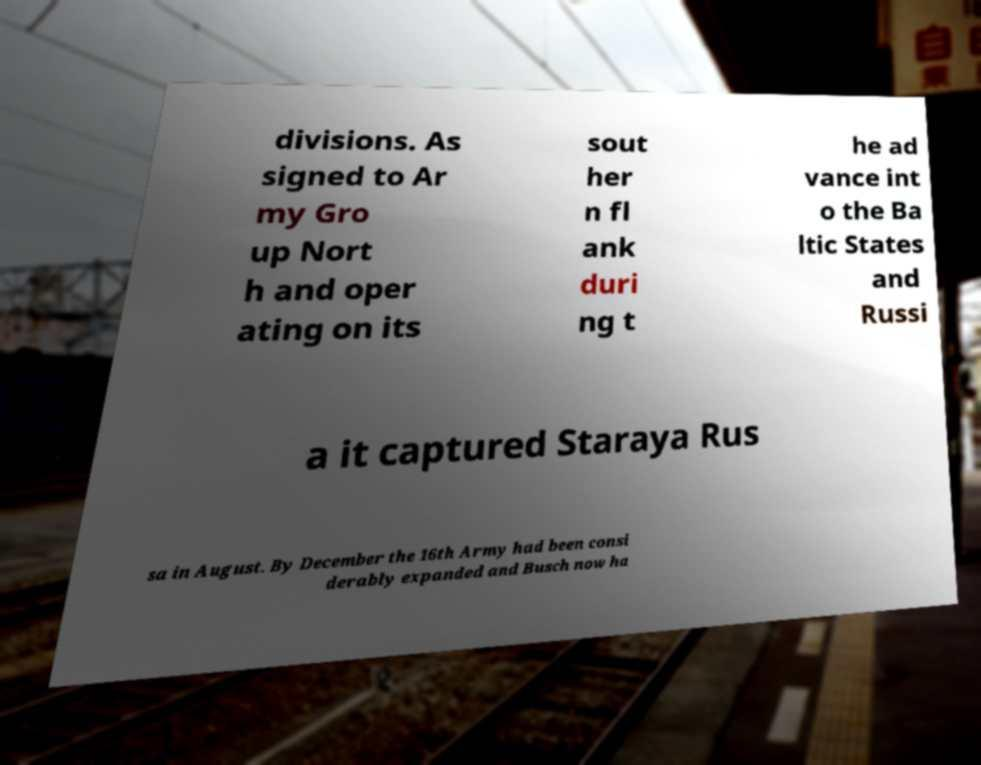Please identify and transcribe the text found in this image. divisions. As signed to Ar my Gro up Nort h and oper ating on its sout her n fl ank duri ng t he ad vance int o the Ba ltic States and Russi a it captured Staraya Rus sa in August. By December the 16th Army had been consi derably expanded and Busch now ha 